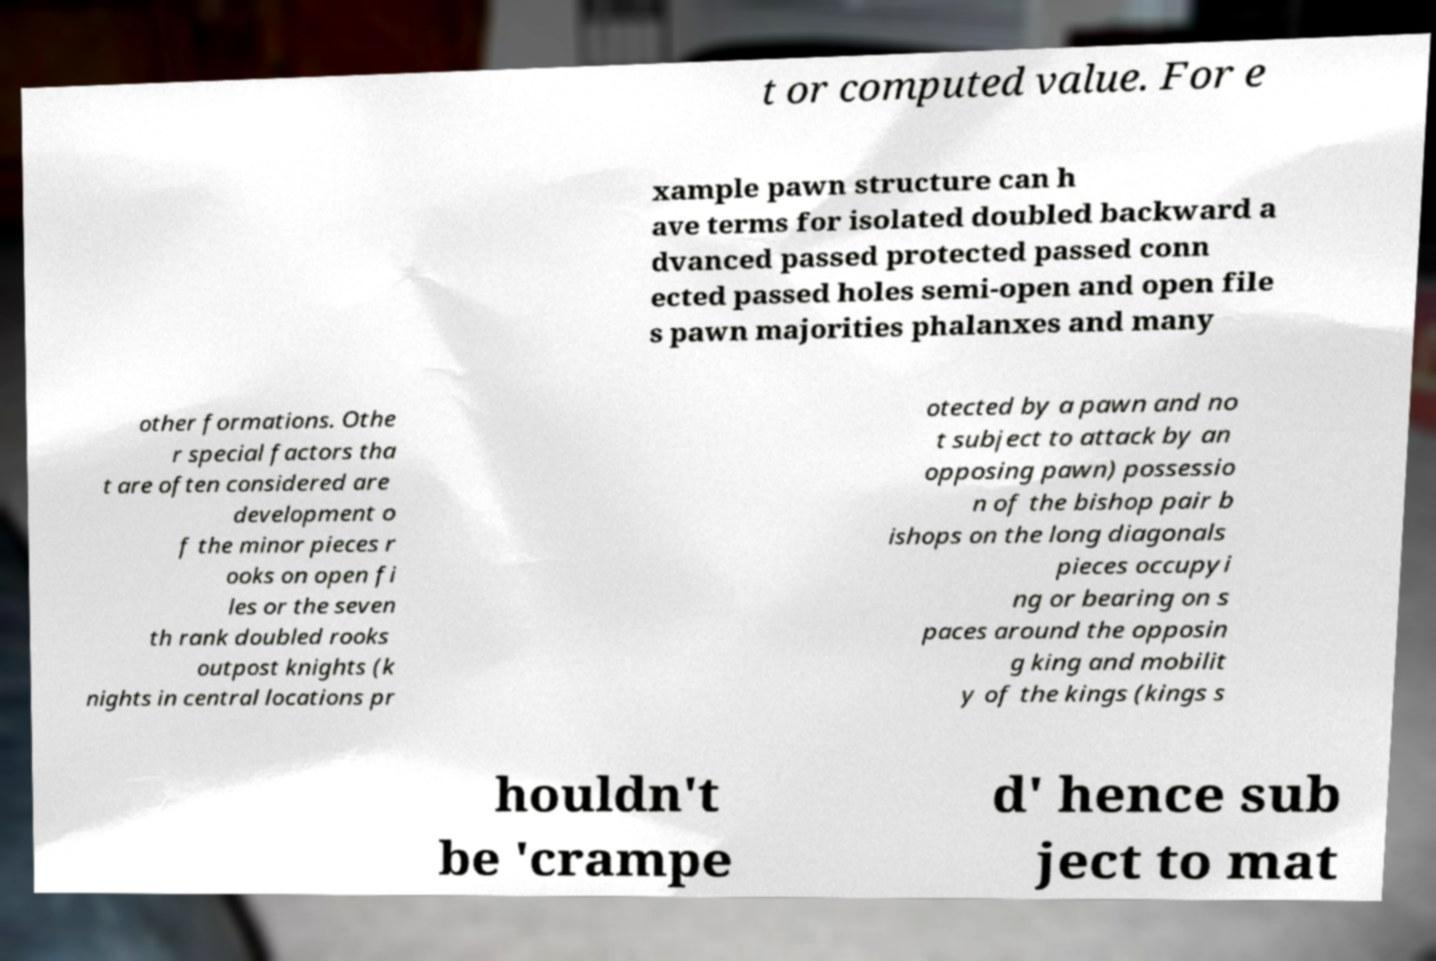Please read and relay the text visible in this image. What does it say? t or computed value. For e xample pawn structure can h ave terms for isolated doubled backward a dvanced passed protected passed conn ected passed holes semi-open and open file s pawn majorities phalanxes and many other formations. Othe r special factors tha t are often considered are development o f the minor pieces r ooks on open fi les or the seven th rank doubled rooks outpost knights (k nights in central locations pr otected by a pawn and no t subject to attack by an opposing pawn) possessio n of the bishop pair b ishops on the long diagonals pieces occupyi ng or bearing on s paces around the opposin g king and mobilit y of the kings (kings s houldn't be 'crampe d' hence sub ject to mat 